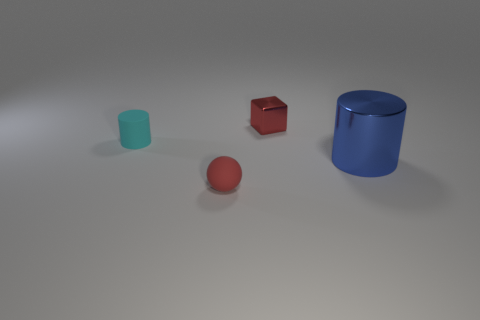Add 3 blue shiny cylinders. How many objects exist? 7 Subtract all balls. How many objects are left? 3 Subtract all small brown matte cylinders. Subtract all tiny cyan objects. How many objects are left? 3 Add 3 small red blocks. How many small red blocks are left? 4 Add 2 small red balls. How many small red balls exist? 3 Subtract 0 purple cylinders. How many objects are left? 4 